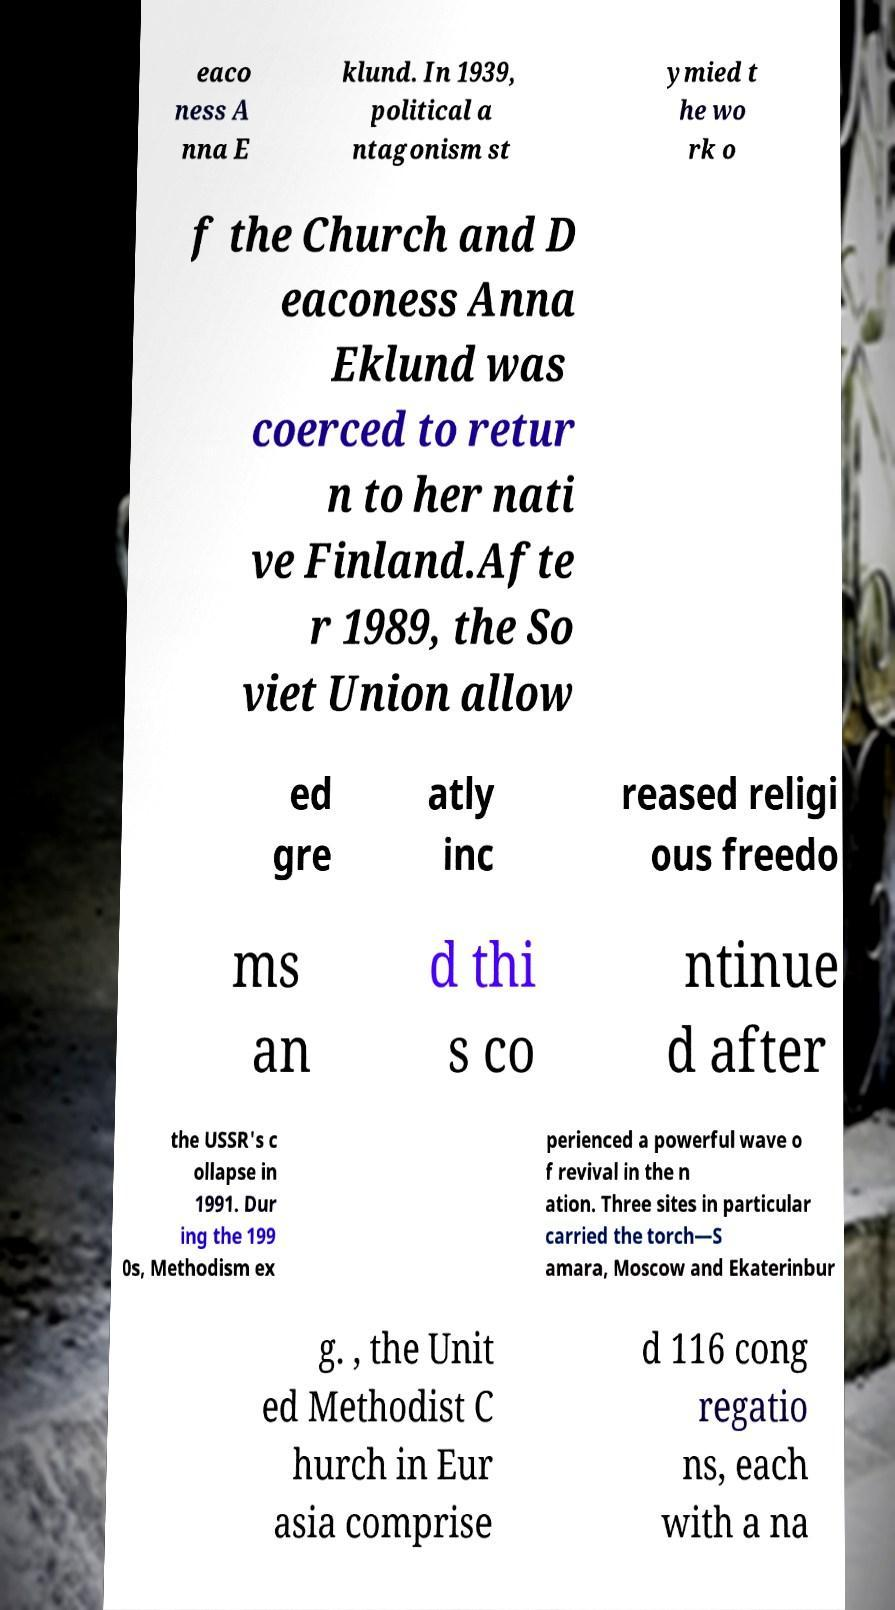Can you accurately transcribe the text from the provided image for me? eaco ness A nna E klund. In 1939, political a ntagonism st ymied t he wo rk o f the Church and D eaconess Anna Eklund was coerced to retur n to her nati ve Finland.Afte r 1989, the So viet Union allow ed gre atly inc reased religi ous freedo ms an d thi s co ntinue d after the USSR's c ollapse in 1991. Dur ing the 199 0s, Methodism ex perienced a powerful wave o f revival in the n ation. Three sites in particular carried the torch—S amara, Moscow and Ekaterinbur g. , the Unit ed Methodist C hurch in Eur asia comprise d 116 cong regatio ns, each with a na 